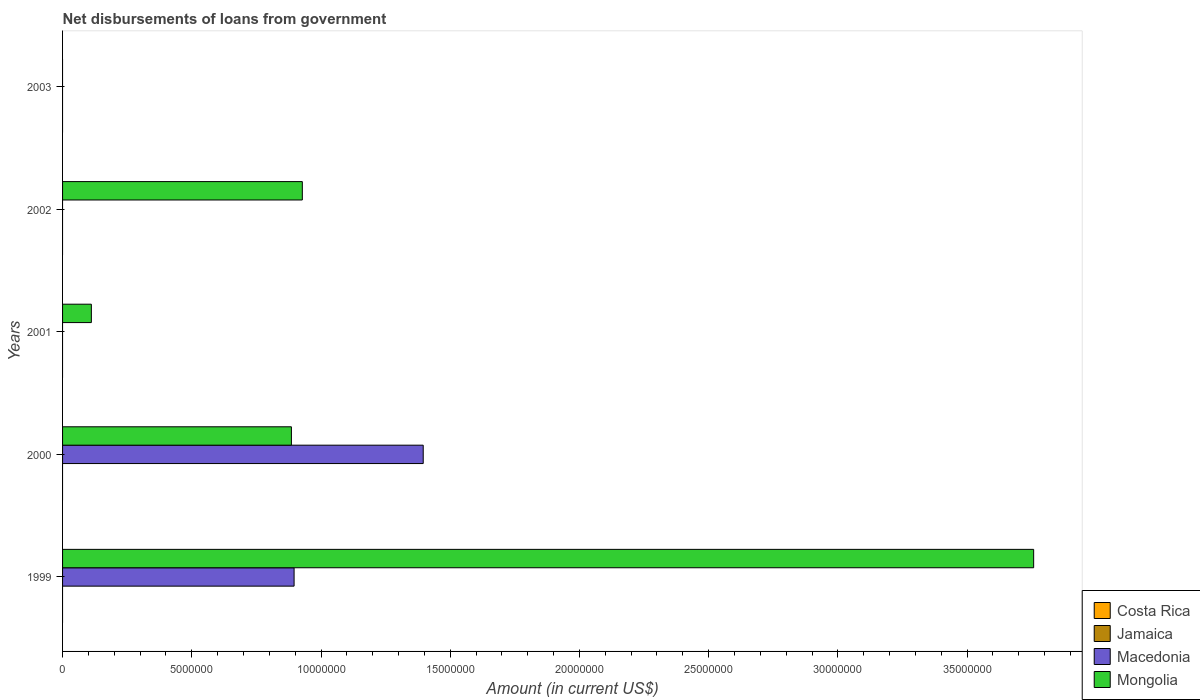How many bars are there on the 2nd tick from the top?
Ensure brevity in your answer.  1. What is the label of the 4th group of bars from the top?
Your answer should be very brief. 2000. In how many cases, is the number of bars for a given year not equal to the number of legend labels?
Offer a very short reply. 5. What is the amount of loan disbursed from government in Mongolia in 2000?
Keep it short and to the point. 8.86e+06. Across all years, what is the maximum amount of loan disbursed from government in Macedonia?
Give a very brief answer. 1.40e+07. In which year was the amount of loan disbursed from government in Mongolia maximum?
Your answer should be compact. 1999. What is the total amount of loan disbursed from government in Macedonia in the graph?
Give a very brief answer. 2.29e+07. What is the difference between the amount of loan disbursed from government in Mongolia in 2000 and that in 2001?
Offer a very short reply. 7.74e+06. What is the difference between the amount of loan disbursed from government in Mongolia in 2000 and the amount of loan disbursed from government in Costa Rica in 2003?
Your answer should be very brief. 8.86e+06. What is the average amount of loan disbursed from government in Jamaica per year?
Your answer should be compact. 0. In the year 2000, what is the difference between the amount of loan disbursed from government in Macedonia and amount of loan disbursed from government in Mongolia?
Your response must be concise. 5.10e+06. In how many years, is the amount of loan disbursed from government in Mongolia greater than 1000000 US$?
Make the answer very short. 4. Is the difference between the amount of loan disbursed from government in Macedonia in 1999 and 2000 greater than the difference between the amount of loan disbursed from government in Mongolia in 1999 and 2000?
Provide a short and direct response. No. What is the difference between the highest and the second highest amount of loan disbursed from government in Mongolia?
Keep it short and to the point. 2.83e+07. What is the difference between the highest and the lowest amount of loan disbursed from government in Mongolia?
Your response must be concise. 3.76e+07. In how many years, is the amount of loan disbursed from government in Mongolia greater than the average amount of loan disbursed from government in Mongolia taken over all years?
Make the answer very short. 1. How many bars are there?
Your answer should be compact. 6. How many years are there in the graph?
Offer a very short reply. 5. What is the difference between two consecutive major ticks on the X-axis?
Make the answer very short. 5.00e+06. How are the legend labels stacked?
Your response must be concise. Vertical. What is the title of the graph?
Your answer should be very brief. Net disbursements of loans from government. What is the label or title of the X-axis?
Ensure brevity in your answer.  Amount (in current US$). What is the Amount (in current US$) in Macedonia in 1999?
Your answer should be very brief. 8.96e+06. What is the Amount (in current US$) in Mongolia in 1999?
Offer a terse response. 3.76e+07. What is the Amount (in current US$) in Macedonia in 2000?
Your answer should be compact. 1.40e+07. What is the Amount (in current US$) in Mongolia in 2000?
Keep it short and to the point. 8.86e+06. What is the Amount (in current US$) in Jamaica in 2001?
Make the answer very short. 0. What is the Amount (in current US$) in Mongolia in 2001?
Offer a very short reply. 1.11e+06. What is the Amount (in current US$) in Jamaica in 2002?
Give a very brief answer. 0. What is the Amount (in current US$) in Macedonia in 2002?
Offer a terse response. 0. What is the Amount (in current US$) in Mongolia in 2002?
Give a very brief answer. 9.28e+06. What is the Amount (in current US$) of Macedonia in 2003?
Provide a short and direct response. 0. What is the Amount (in current US$) in Mongolia in 2003?
Give a very brief answer. 0. Across all years, what is the maximum Amount (in current US$) of Macedonia?
Make the answer very short. 1.40e+07. Across all years, what is the maximum Amount (in current US$) of Mongolia?
Provide a short and direct response. 3.76e+07. Across all years, what is the minimum Amount (in current US$) in Macedonia?
Give a very brief answer. 0. What is the total Amount (in current US$) of Costa Rica in the graph?
Your answer should be compact. 0. What is the total Amount (in current US$) in Macedonia in the graph?
Provide a short and direct response. 2.29e+07. What is the total Amount (in current US$) of Mongolia in the graph?
Keep it short and to the point. 5.68e+07. What is the difference between the Amount (in current US$) in Macedonia in 1999 and that in 2000?
Offer a terse response. -5.00e+06. What is the difference between the Amount (in current US$) in Mongolia in 1999 and that in 2000?
Your response must be concise. 2.87e+07. What is the difference between the Amount (in current US$) in Mongolia in 1999 and that in 2001?
Offer a terse response. 3.65e+07. What is the difference between the Amount (in current US$) in Mongolia in 1999 and that in 2002?
Provide a short and direct response. 2.83e+07. What is the difference between the Amount (in current US$) in Mongolia in 2000 and that in 2001?
Provide a short and direct response. 7.74e+06. What is the difference between the Amount (in current US$) of Mongolia in 2000 and that in 2002?
Offer a very short reply. -4.23e+05. What is the difference between the Amount (in current US$) of Mongolia in 2001 and that in 2002?
Offer a very short reply. -8.16e+06. What is the difference between the Amount (in current US$) of Macedonia in 1999 and the Amount (in current US$) of Mongolia in 2000?
Offer a very short reply. 1.04e+05. What is the difference between the Amount (in current US$) in Macedonia in 1999 and the Amount (in current US$) in Mongolia in 2001?
Your response must be concise. 7.84e+06. What is the difference between the Amount (in current US$) of Macedonia in 1999 and the Amount (in current US$) of Mongolia in 2002?
Your answer should be compact. -3.19e+05. What is the difference between the Amount (in current US$) in Macedonia in 2000 and the Amount (in current US$) in Mongolia in 2001?
Provide a succinct answer. 1.28e+07. What is the difference between the Amount (in current US$) in Macedonia in 2000 and the Amount (in current US$) in Mongolia in 2002?
Keep it short and to the point. 4.68e+06. What is the average Amount (in current US$) in Costa Rica per year?
Provide a short and direct response. 0. What is the average Amount (in current US$) in Jamaica per year?
Offer a terse response. 0. What is the average Amount (in current US$) of Macedonia per year?
Provide a succinct answer. 4.58e+06. What is the average Amount (in current US$) in Mongolia per year?
Your answer should be very brief. 1.14e+07. In the year 1999, what is the difference between the Amount (in current US$) in Macedonia and Amount (in current US$) in Mongolia?
Offer a terse response. -2.86e+07. In the year 2000, what is the difference between the Amount (in current US$) of Macedonia and Amount (in current US$) of Mongolia?
Provide a short and direct response. 5.10e+06. What is the ratio of the Amount (in current US$) of Macedonia in 1999 to that in 2000?
Ensure brevity in your answer.  0.64. What is the ratio of the Amount (in current US$) of Mongolia in 1999 to that in 2000?
Your answer should be very brief. 4.24. What is the ratio of the Amount (in current US$) in Mongolia in 1999 to that in 2001?
Make the answer very short. 33.73. What is the ratio of the Amount (in current US$) in Mongolia in 1999 to that in 2002?
Make the answer very short. 4.05. What is the ratio of the Amount (in current US$) of Mongolia in 2000 to that in 2001?
Provide a succinct answer. 7.95. What is the ratio of the Amount (in current US$) of Mongolia in 2000 to that in 2002?
Your answer should be compact. 0.95. What is the ratio of the Amount (in current US$) in Mongolia in 2001 to that in 2002?
Ensure brevity in your answer.  0.12. What is the difference between the highest and the second highest Amount (in current US$) in Mongolia?
Provide a short and direct response. 2.83e+07. What is the difference between the highest and the lowest Amount (in current US$) of Macedonia?
Ensure brevity in your answer.  1.40e+07. What is the difference between the highest and the lowest Amount (in current US$) of Mongolia?
Provide a succinct answer. 3.76e+07. 